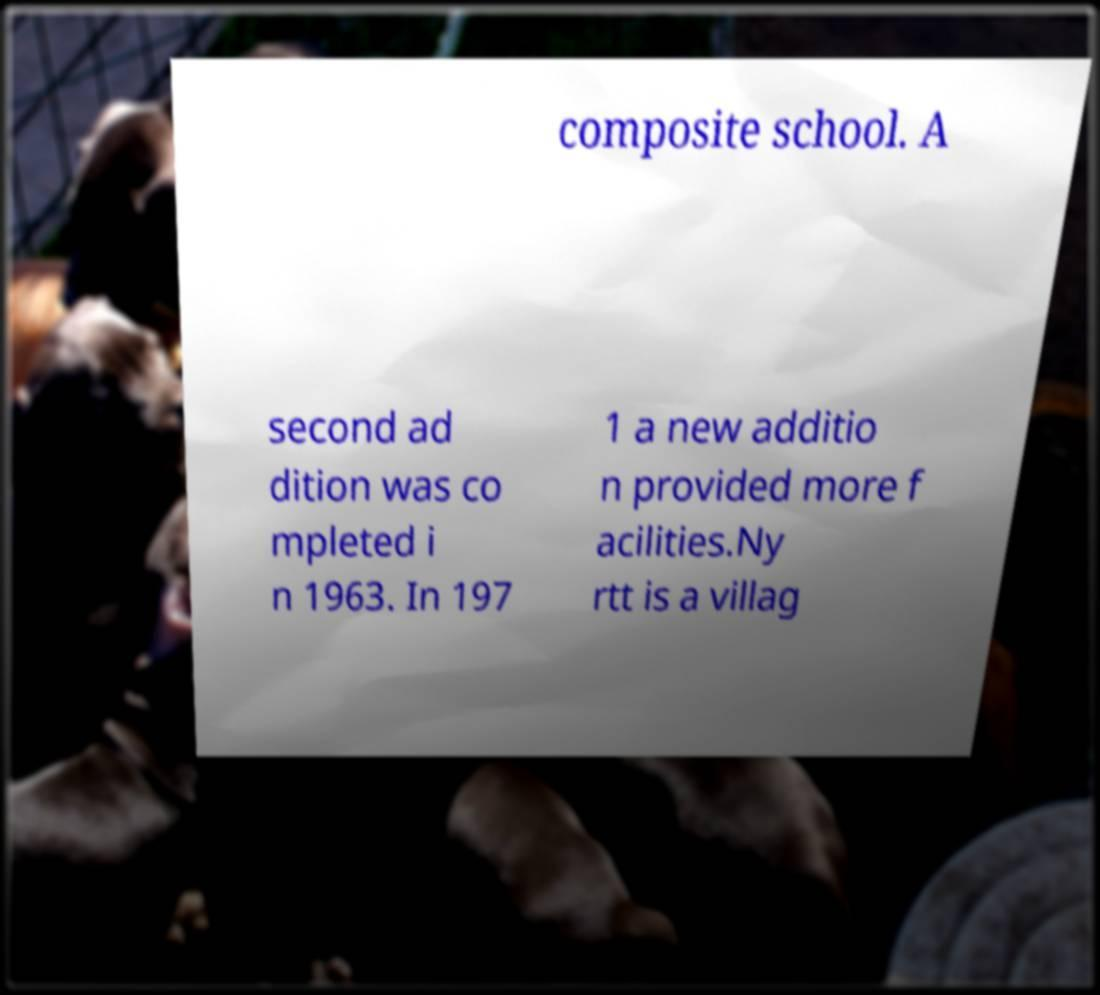There's text embedded in this image that I need extracted. Can you transcribe it verbatim? composite school. A second ad dition was co mpleted i n 1963. In 197 1 a new additio n provided more f acilities.Ny rtt is a villag 